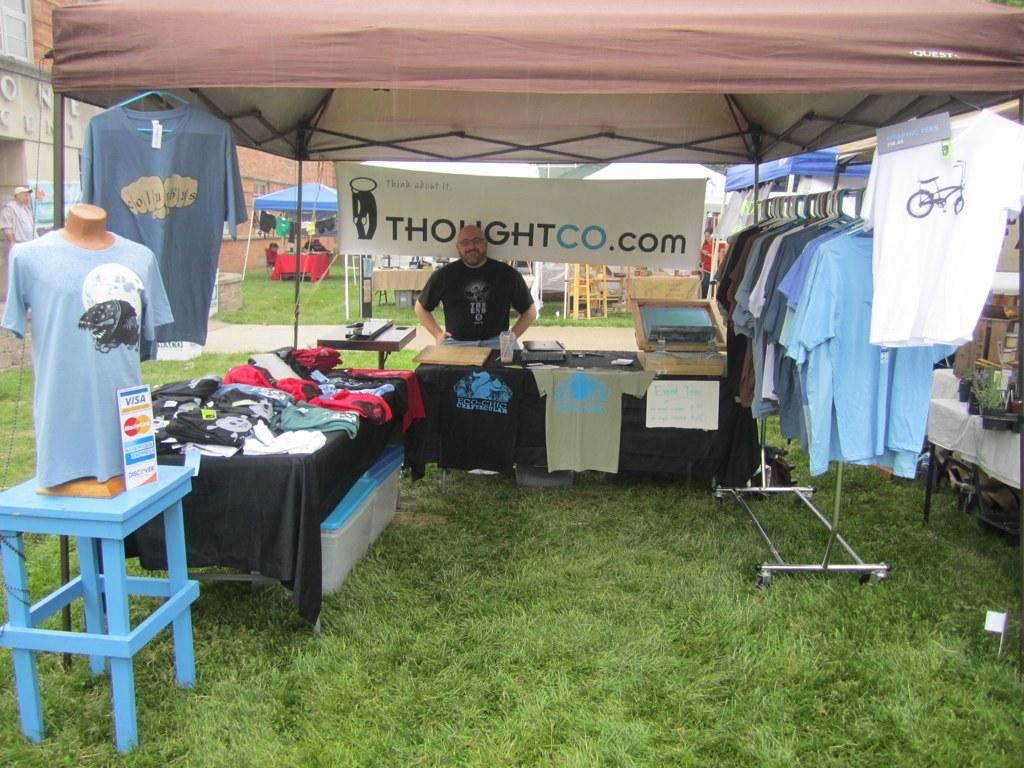Where is the man located in the image? The man is in a stall in the image. What can be seen on the table in the image? There are clothes on a table in the image. How are the clothes arranged in the image? The clothes are hanging in the image. What type of surface is visible in the image? There is grass visible in the image. What piece of furniture is present in the image? There is a stool in the image. What is placed on the stool in the image? A mannequin is placed on the stool in the image. Where is the sink located in the image? There is no sink present in the image. How many babies are visible in the image? There are no babies visible in the image. 